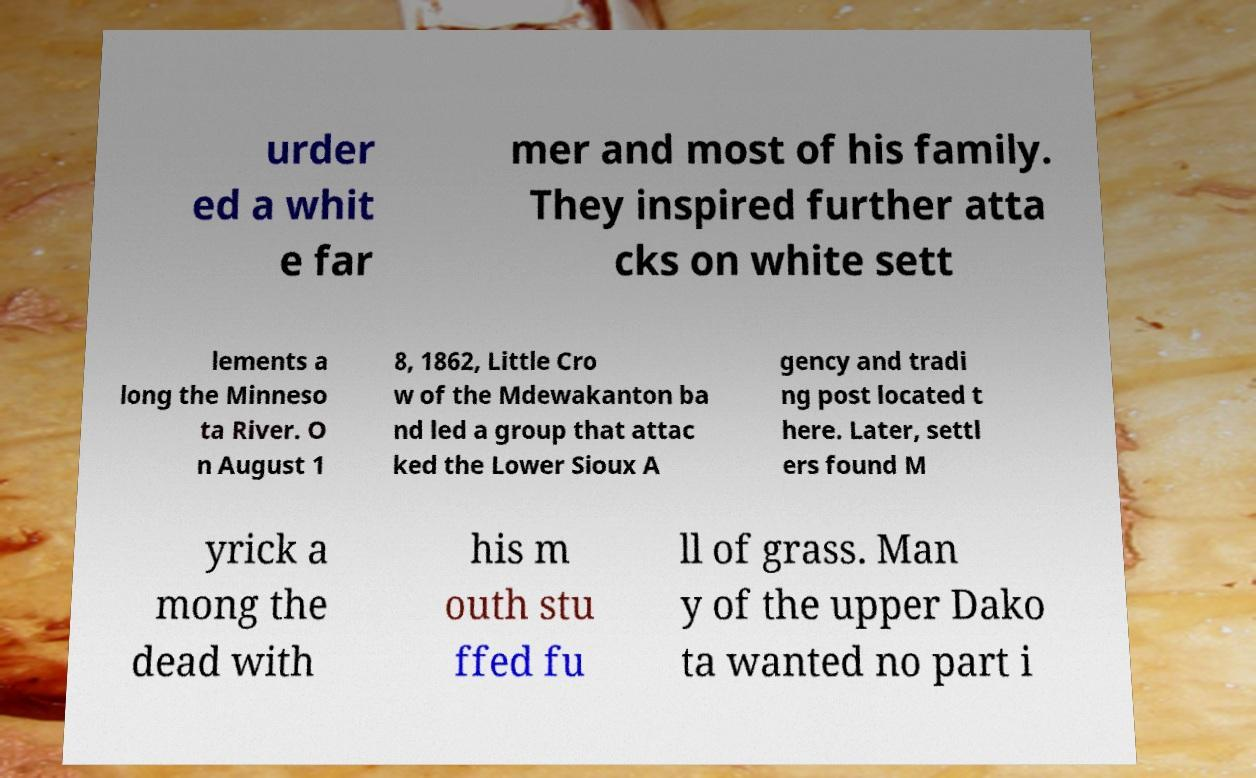What messages or text are displayed in this image? I need them in a readable, typed format. urder ed a whit e far mer and most of his family. They inspired further atta cks on white sett lements a long the Minneso ta River. O n August 1 8, 1862, Little Cro w of the Mdewakanton ba nd led a group that attac ked the Lower Sioux A gency and tradi ng post located t here. Later, settl ers found M yrick a mong the dead with his m outh stu ffed fu ll of grass. Man y of the upper Dako ta wanted no part i 